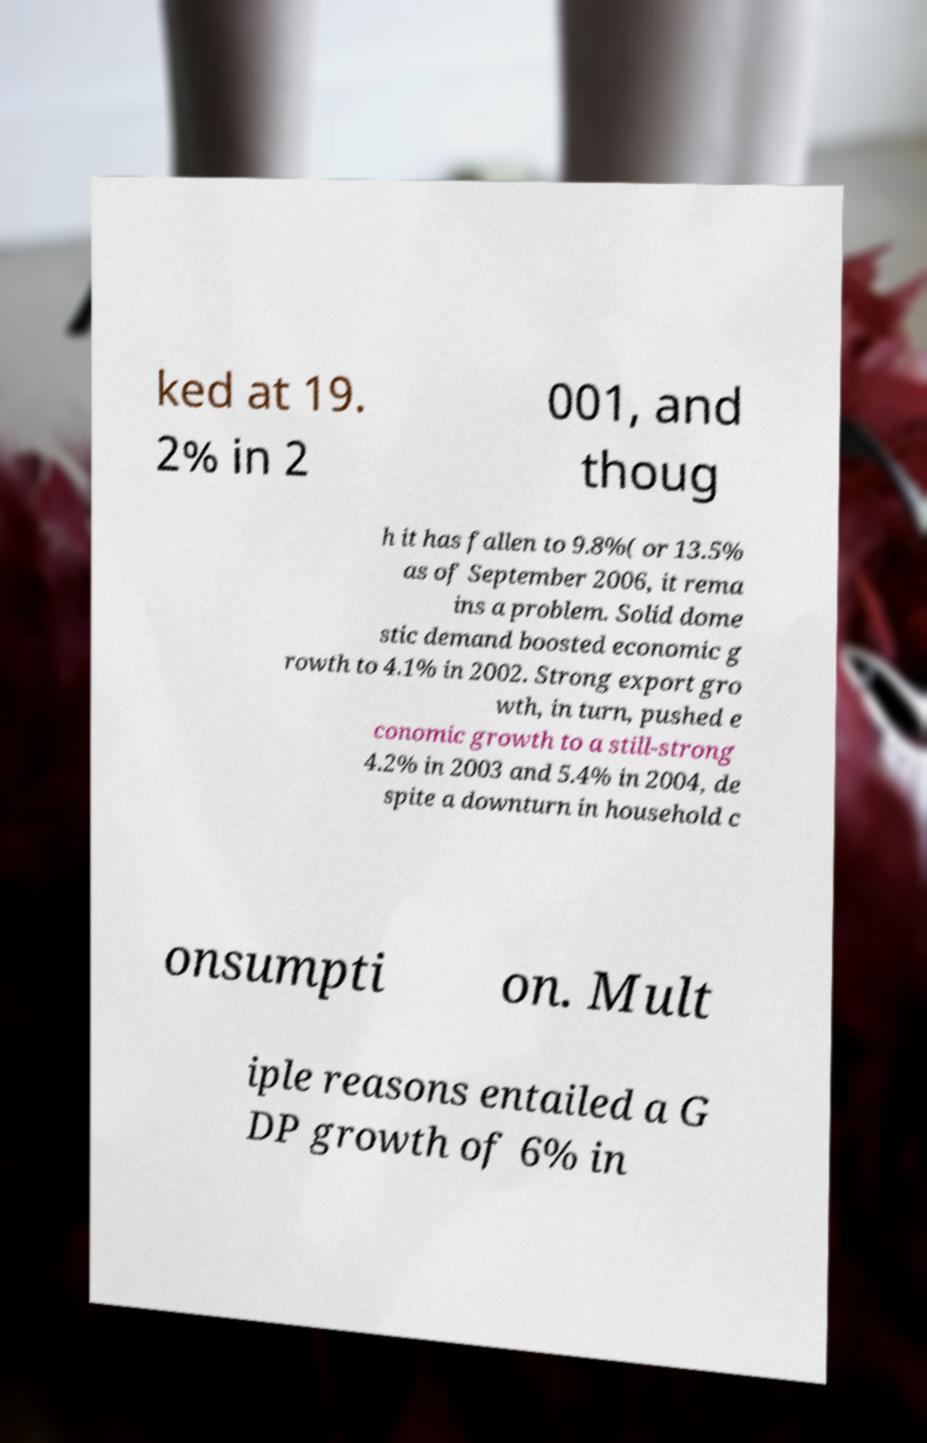Could you assist in decoding the text presented in this image and type it out clearly? ked at 19. 2% in 2 001, and thoug h it has fallen to 9.8%( or 13.5% as of September 2006, it rema ins a problem. Solid dome stic demand boosted economic g rowth to 4.1% in 2002. Strong export gro wth, in turn, pushed e conomic growth to a still-strong 4.2% in 2003 and 5.4% in 2004, de spite a downturn in household c onsumpti on. Mult iple reasons entailed a G DP growth of 6% in 